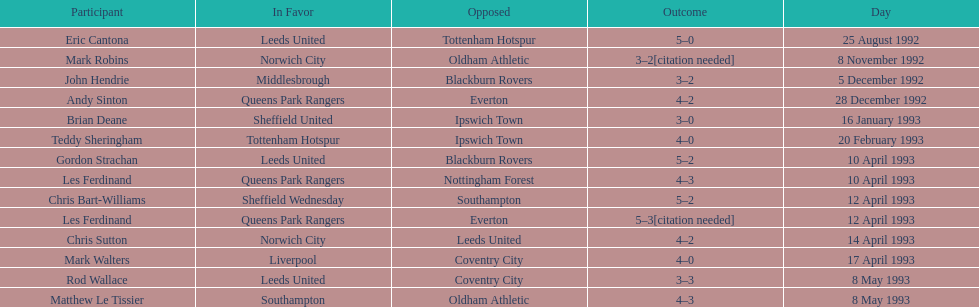Name the only player from france. Eric Cantona. 